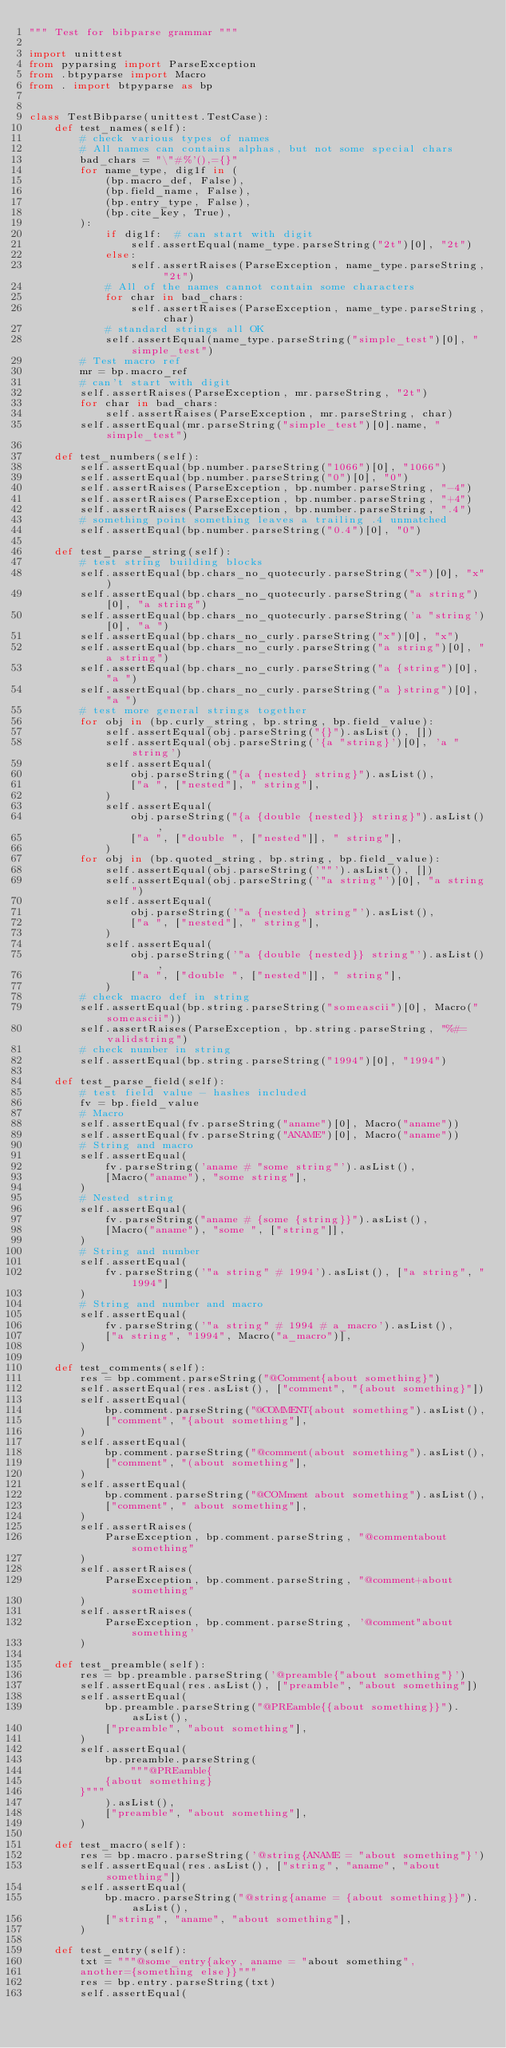Convert code to text. <code><loc_0><loc_0><loc_500><loc_500><_Python_>""" Test for bibparse grammar """

import unittest
from pyparsing import ParseException
from .btpyparse import Macro
from . import btpyparse as bp


class TestBibparse(unittest.TestCase):
    def test_names(self):
        # check various types of names
        # All names can contains alphas, but not some special chars
        bad_chars = "\"#%'(),={}"
        for name_type, dig1f in (
            (bp.macro_def, False),
            (bp.field_name, False),
            (bp.entry_type, False),
            (bp.cite_key, True),
        ):
            if dig1f:  # can start with digit
                self.assertEqual(name_type.parseString("2t")[0], "2t")
            else:
                self.assertRaises(ParseException, name_type.parseString, "2t")
            # All of the names cannot contain some characters
            for char in bad_chars:
                self.assertRaises(ParseException, name_type.parseString, char)
            # standard strings all OK
            self.assertEqual(name_type.parseString("simple_test")[0], "simple_test")
        # Test macro ref
        mr = bp.macro_ref
        # can't start with digit
        self.assertRaises(ParseException, mr.parseString, "2t")
        for char in bad_chars:
            self.assertRaises(ParseException, mr.parseString, char)
        self.assertEqual(mr.parseString("simple_test")[0].name, "simple_test")

    def test_numbers(self):
        self.assertEqual(bp.number.parseString("1066")[0], "1066")
        self.assertEqual(bp.number.parseString("0")[0], "0")
        self.assertRaises(ParseException, bp.number.parseString, "-4")
        self.assertRaises(ParseException, bp.number.parseString, "+4")
        self.assertRaises(ParseException, bp.number.parseString, ".4")
        # something point something leaves a trailing .4 unmatched
        self.assertEqual(bp.number.parseString("0.4")[0], "0")

    def test_parse_string(self):
        # test string building blocks
        self.assertEqual(bp.chars_no_quotecurly.parseString("x")[0], "x")
        self.assertEqual(bp.chars_no_quotecurly.parseString("a string")[0], "a string")
        self.assertEqual(bp.chars_no_quotecurly.parseString('a "string')[0], "a ")
        self.assertEqual(bp.chars_no_curly.parseString("x")[0], "x")
        self.assertEqual(bp.chars_no_curly.parseString("a string")[0], "a string")
        self.assertEqual(bp.chars_no_curly.parseString("a {string")[0], "a ")
        self.assertEqual(bp.chars_no_curly.parseString("a }string")[0], "a ")
        # test more general strings together
        for obj in (bp.curly_string, bp.string, bp.field_value):
            self.assertEqual(obj.parseString("{}").asList(), [])
            self.assertEqual(obj.parseString('{a "string}')[0], 'a "string')
            self.assertEqual(
                obj.parseString("{a {nested} string}").asList(),
                ["a ", ["nested"], " string"],
            )
            self.assertEqual(
                obj.parseString("{a {double {nested}} string}").asList(),
                ["a ", ["double ", ["nested"]], " string"],
            )
        for obj in (bp.quoted_string, bp.string, bp.field_value):
            self.assertEqual(obj.parseString('""').asList(), [])
            self.assertEqual(obj.parseString('"a string"')[0], "a string")
            self.assertEqual(
                obj.parseString('"a {nested} string"').asList(),
                ["a ", ["nested"], " string"],
            )
            self.assertEqual(
                obj.parseString('"a {double {nested}} string"').asList(),
                ["a ", ["double ", ["nested"]], " string"],
            )
        # check macro def in string
        self.assertEqual(bp.string.parseString("someascii")[0], Macro("someascii"))
        self.assertRaises(ParseException, bp.string.parseString, "%#= validstring")
        # check number in string
        self.assertEqual(bp.string.parseString("1994")[0], "1994")

    def test_parse_field(self):
        # test field value - hashes included
        fv = bp.field_value
        # Macro
        self.assertEqual(fv.parseString("aname")[0], Macro("aname"))
        self.assertEqual(fv.parseString("ANAME")[0], Macro("aname"))
        # String and macro
        self.assertEqual(
            fv.parseString('aname # "some string"').asList(),
            [Macro("aname"), "some string"],
        )
        # Nested string
        self.assertEqual(
            fv.parseString("aname # {some {string}}").asList(),
            [Macro("aname"), "some ", ["string"]],
        )
        # String and number
        self.assertEqual(
            fv.parseString('"a string" # 1994').asList(), ["a string", "1994"]
        )
        # String and number and macro
        self.assertEqual(
            fv.parseString('"a string" # 1994 # a_macro').asList(),
            ["a string", "1994", Macro("a_macro")],
        )

    def test_comments(self):
        res = bp.comment.parseString("@Comment{about something}")
        self.assertEqual(res.asList(), ["comment", "{about something}"])
        self.assertEqual(
            bp.comment.parseString("@COMMENT{about something").asList(),
            ["comment", "{about something"],
        )
        self.assertEqual(
            bp.comment.parseString("@comment(about something").asList(),
            ["comment", "(about something"],
        )
        self.assertEqual(
            bp.comment.parseString("@COMment about something").asList(),
            ["comment", " about something"],
        )
        self.assertRaises(
            ParseException, bp.comment.parseString, "@commentabout something"
        )
        self.assertRaises(
            ParseException, bp.comment.parseString, "@comment+about something"
        )
        self.assertRaises(
            ParseException, bp.comment.parseString, '@comment"about something'
        )

    def test_preamble(self):
        res = bp.preamble.parseString('@preamble{"about something"}')
        self.assertEqual(res.asList(), ["preamble", "about something"])
        self.assertEqual(
            bp.preamble.parseString("@PREamble{{about something}}").asList(),
            ["preamble", "about something"],
        )
        self.assertEqual(
            bp.preamble.parseString(
                """@PREamble{
            {about something}
        }"""
            ).asList(),
            ["preamble", "about something"],
        )

    def test_macro(self):
        res = bp.macro.parseString('@string{ANAME = "about something"}')
        self.assertEqual(res.asList(), ["string", "aname", "about something"])
        self.assertEqual(
            bp.macro.parseString("@string{aname = {about something}}").asList(),
            ["string", "aname", "about something"],
        )

    def test_entry(self):
        txt = """@some_entry{akey, aname = "about something",
        another={something else}}"""
        res = bp.entry.parseString(txt)
        self.assertEqual(</code> 